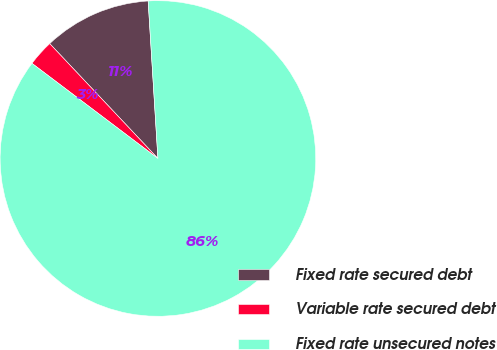Convert chart to OTSL. <chart><loc_0><loc_0><loc_500><loc_500><pie_chart><fcel>Fixed rate secured debt<fcel>Variable rate secured debt<fcel>Fixed rate unsecured notes<nl><fcel>11.04%<fcel>2.68%<fcel>86.28%<nl></chart> 